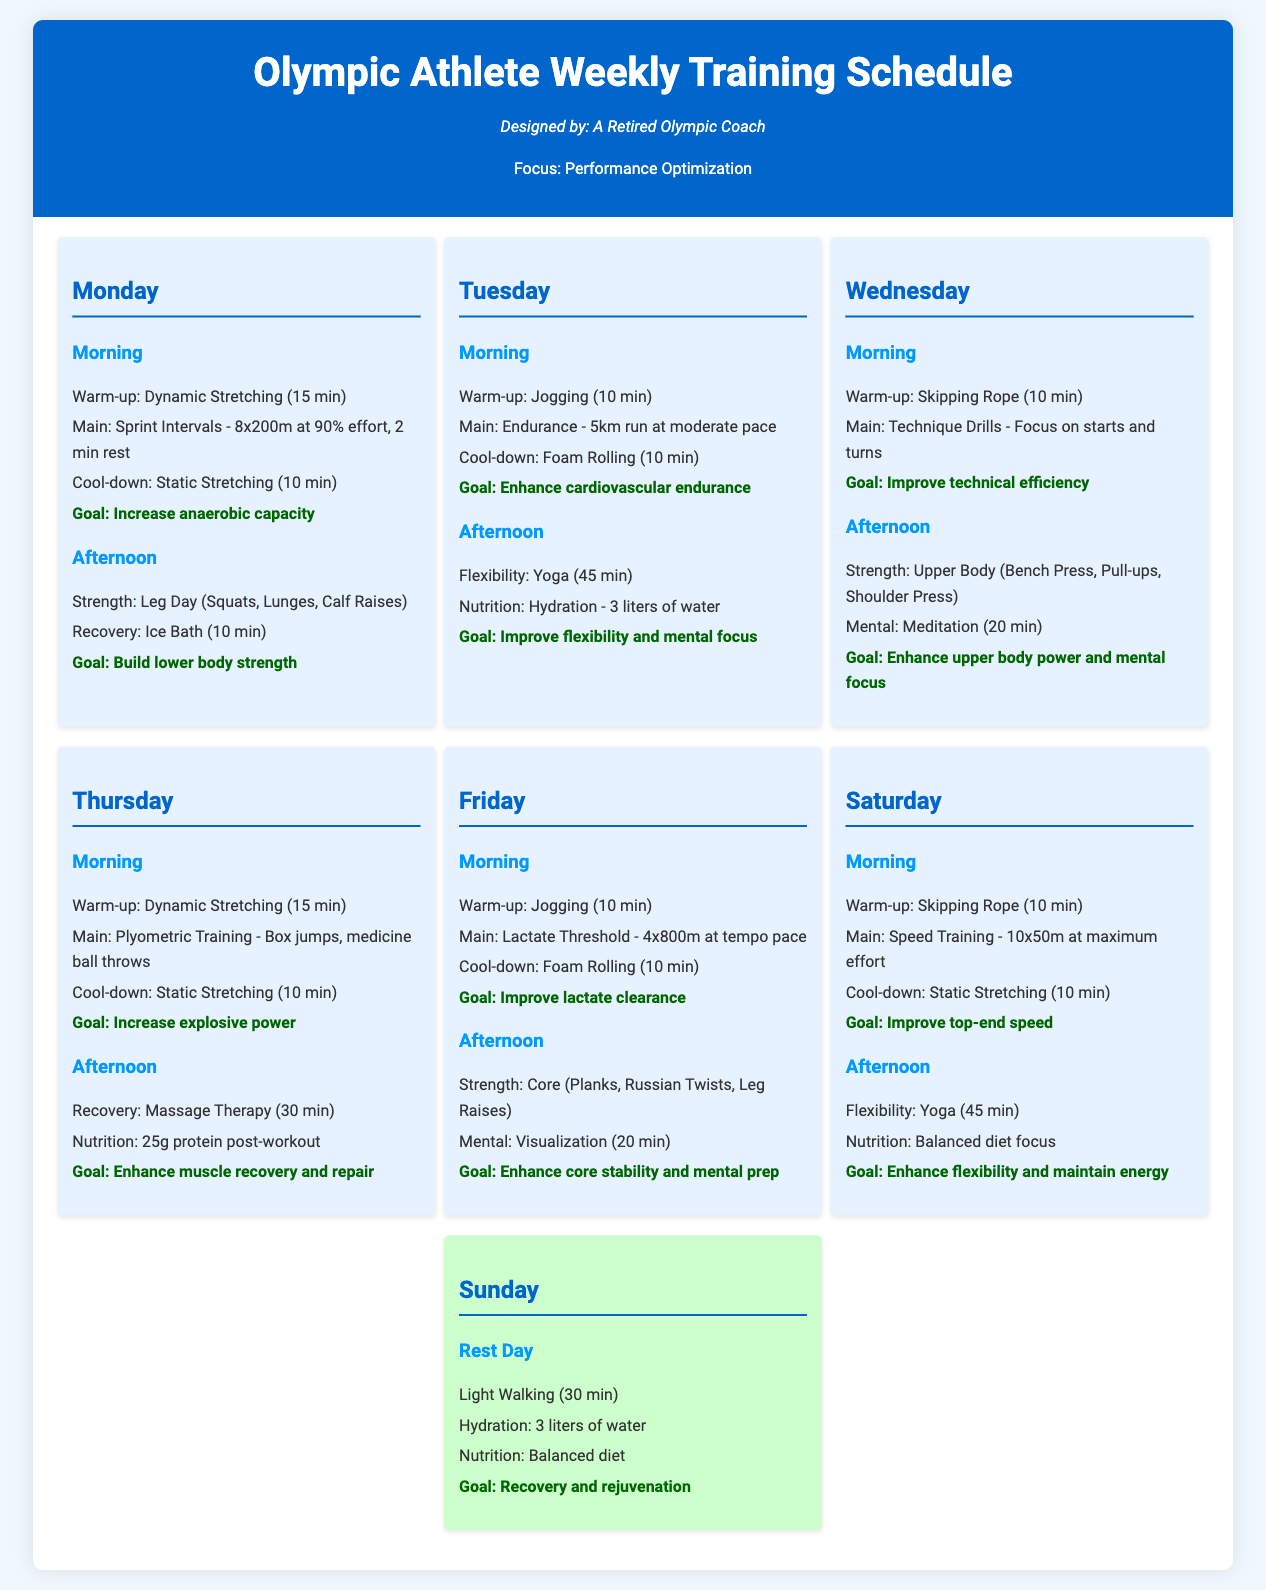what is the main goal of Monday's training? The main goal for Monday's training is to increase anaerobic capacity as stated in the document.
Answer: Increase anaerobic capacity how long does the Tuesday morning warm-up last? The Tuesday morning warm-up consists of jogging for 10 minutes, as indicated in the schedule.
Answer: 10 min what type of recovery activity is scheduled for Thursday afternoon? Thursday afternoon includes massage therapy as a recovery activity according to the training schedule.
Answer: Massage Therapy how many sprint intervals are included in Monday's morning session? Monday's morning session includes 8 sprint intervals of 200 meters, specified in the document.
Answer: 8x200m what is the total amount of water recommended for hydration on Tuesday? The document specifies a total of 3 liters of water for hydration on Tuesday.
Answer: 3 liters what is the duration of yoga sessions scheduled on Saturday? The yoga session scheduled on Saturday has a duration of 45 minutes as detailed in the training plan.
Answer: 45 min where is the rest day placed within the training schedule? The rest day is scheduled for Sunday as mentioned in the document.
Answer: Sunday what type of training is focused on Wednesday morning? Wednesday morning focuses on technique drills as stated in the weekly training schedule.
Answer: Technique Drills what is emphasized during Friday afternoon's mental exercise? Friday afternoon emphasizes visualization as a mental exercise, according to the schedule.
Answer: Visualization 